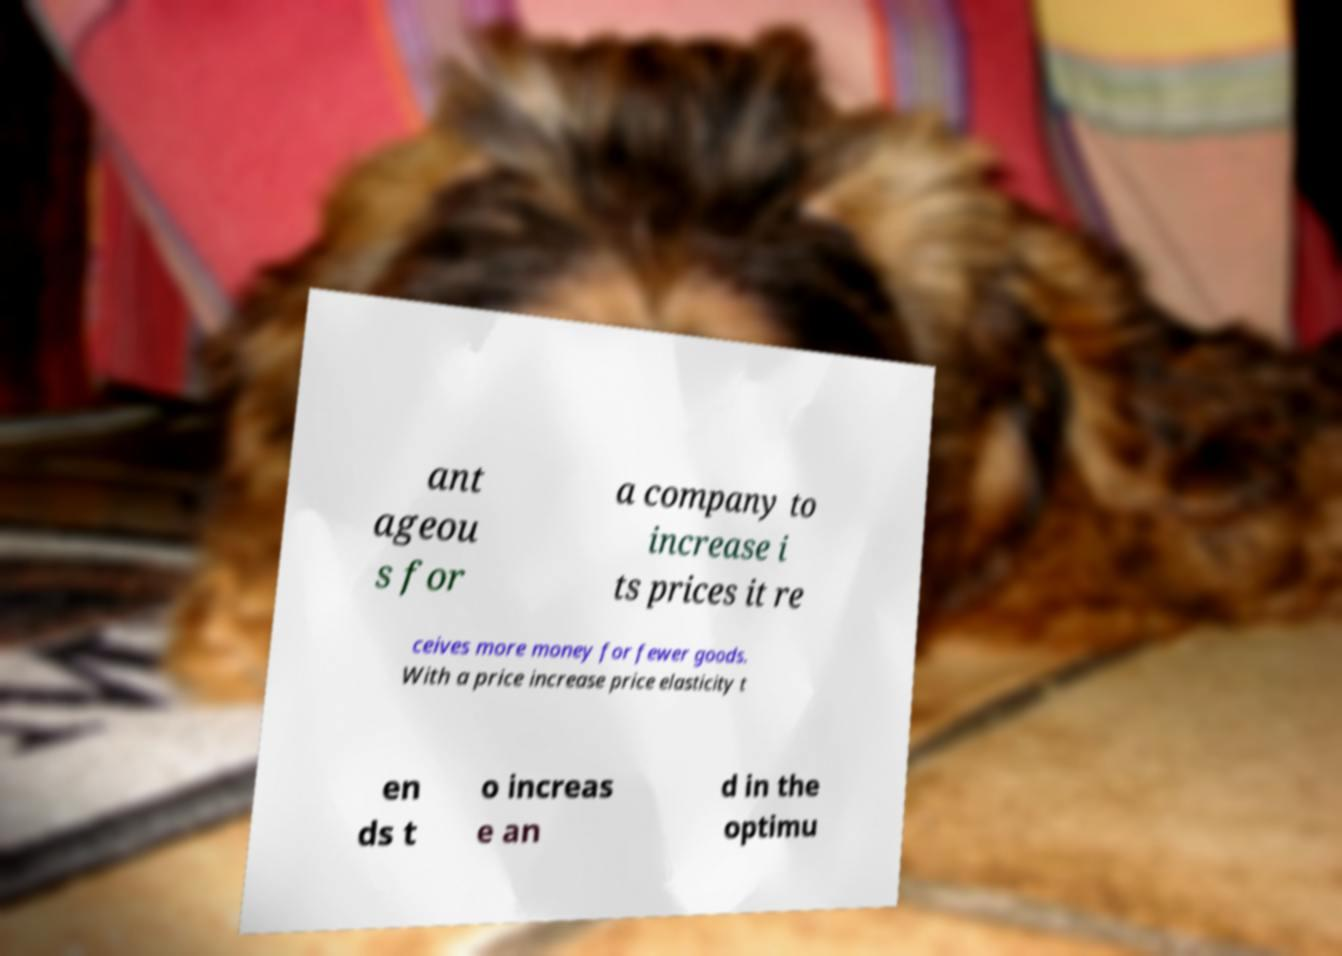What messages or text are displayed in this image? I need them in a readable, typed format. ant ageou s for a company to increase i ts prices it re ceives more money for fewer goods. With a price increase price elasticity t en ds t o increas e an d in the optimu 